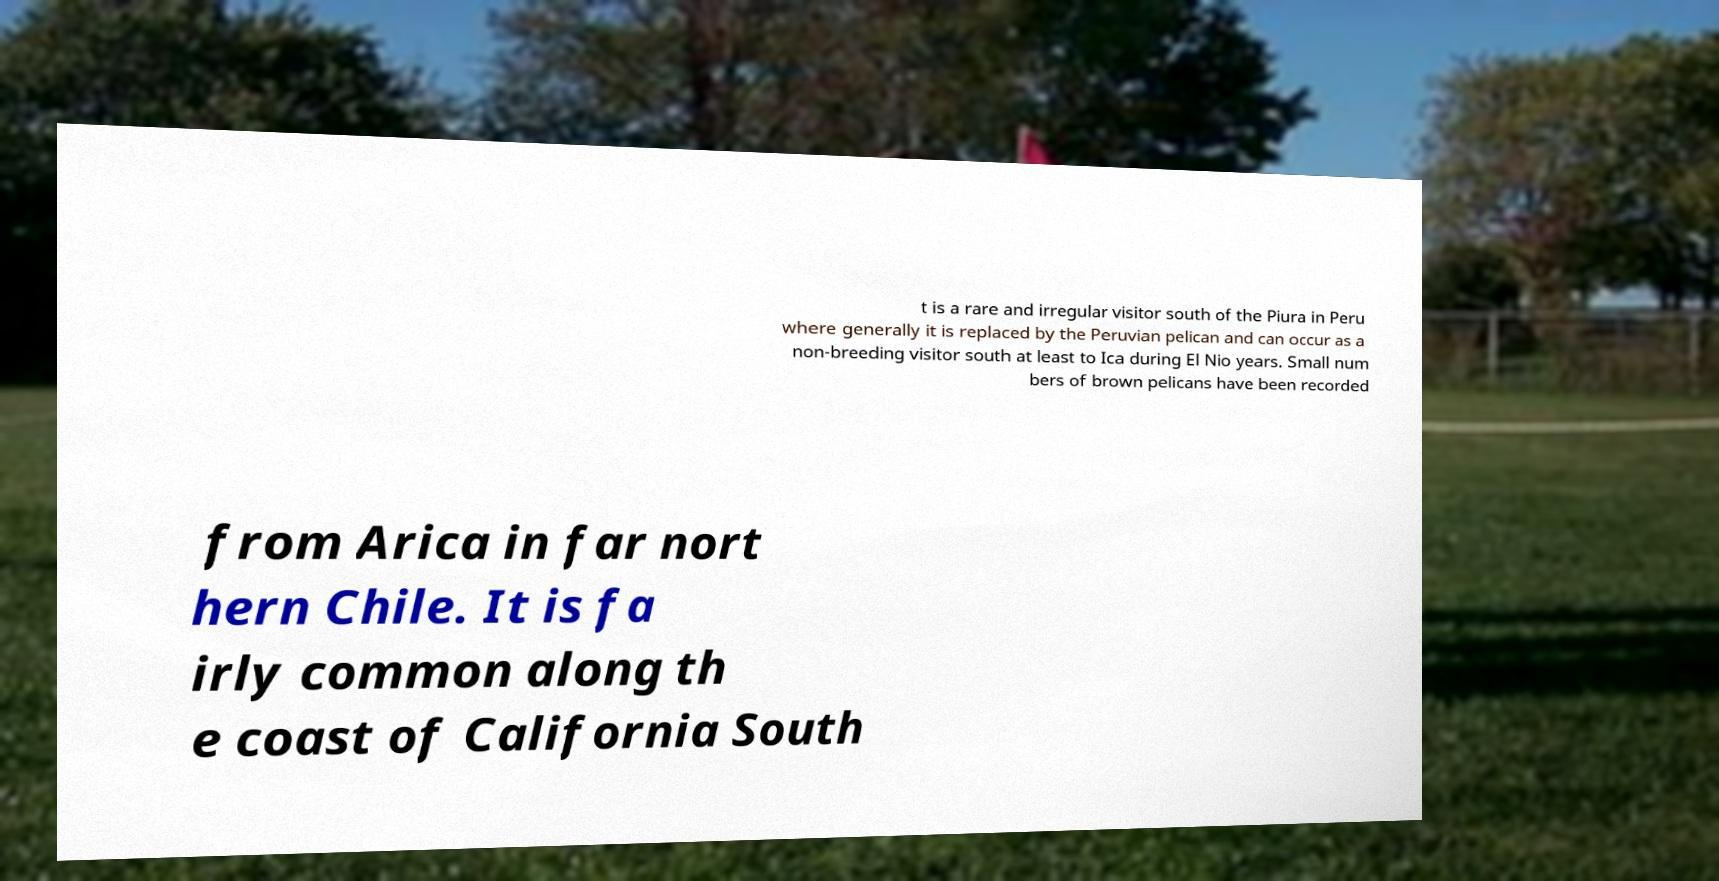Could you assist in decoding the text presented in this image and type it out clearly? t is a rare and irregular visitor south of the Piura in Peru where generally it is replaced by the Peruvian pelican and can occur as a non-breeding visitor south at least to Ica during El Nio years. Small num bers of brown pelicans have been recorded from Arica in far nort hern Chile. It is fa irly common along th e coast of California South 